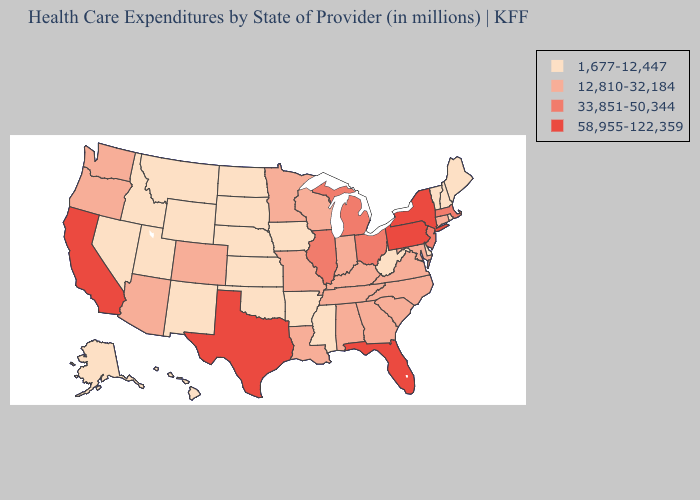Among the states that border Mississippi , which have the highest value?
Short answer required. Alabama, Louisiana, Tennessee. Does New Hampshire have the lowest value in the Northeast?
Short answer required. Yes. What is the value of Iowa?
Give a very brief answer. 1,677-12,447. Which states have the lowest value in the MidWest?
Short answer required. Iowa, Kansas, Nebraska, North Dakota, South Dakota. Among the states that border Massachusetts , does New Hampshire have the highest value?
Keep it brief. No. What is the value of Maryland?
Short answer required. 12,810-32,184. What is the value of Oregon?
Give a very brief answer. 12,810-32,184. Among the states that border Maryland , which have the highest value?
Quick response, please. Pennsylvania. How many symbols are there in the legend?
Short answer required. 4. Does Wisconsin have the lowest value in the MidWest?
Keep it brief. No. Among the states that border Indiana , does Kentucky have the lowest value?
Quick response, please. Yes. Name the states that have a value in the range 12,810-32,184?
Concise answer only. Alabama, Arizona, Colorado, Connecticut, Georgia, Indiana, Kentucky, Louisiana, Maryland, Minnesota, Missouri, North Carolina, Oregon, South Carolina, Tennessee, Virginia, Washington, Wisconsin. How many symbols are there in the legend?
Write a very short answer. 4. Name the states that have a value in the range 12,810-32,184?
Short answer required. Alabama, Arizona, Colorado, Connecticut, Georgia, Indiana, Kentucky, Louisiana, Maryland, Minnesota, Missouri, North Carolina, Oregon, South Carolina, Tennessee, Virginia, Washington, Wisconsin. Name the states that have a value in the range 58,955-122,359?
Give a very brief answer. California, Florida, New York, Pennsylvania, Texas. 